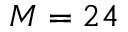Convert formula to latex. <formula><loc_0><loc_0><loc_500><loc_500>M = 2 4</formula> 